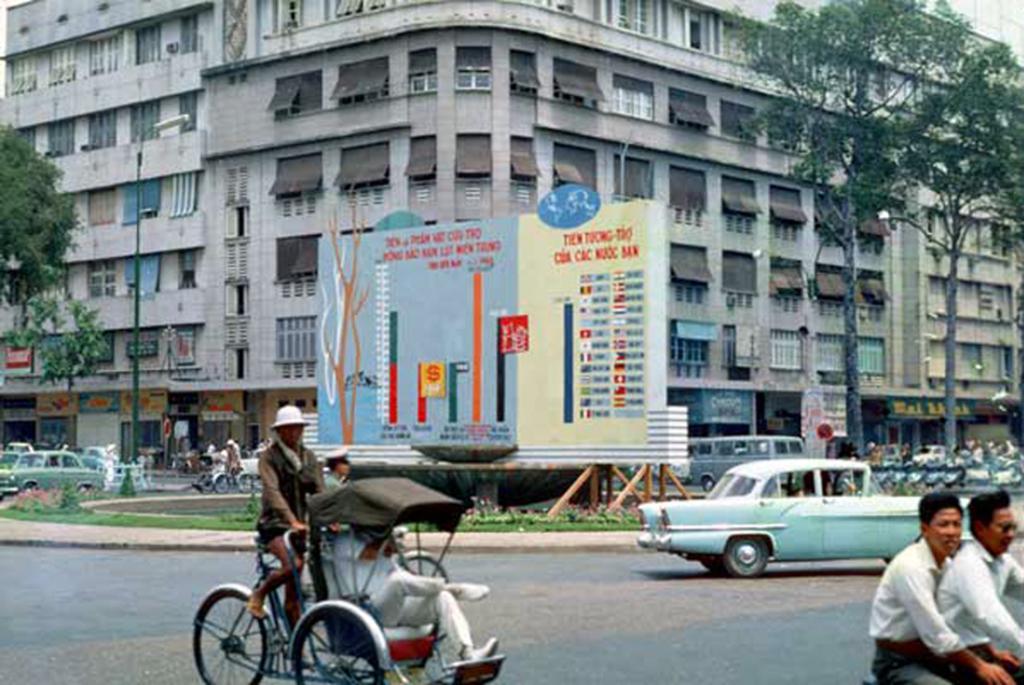Can you describe this image briefly? On the right side of the image, there are two persons sitting on the bike wearing two white color shirts. In the background, there is a car moving on the road, hoarding, trees, building, cars, grass and other items. On the left side of the image, a man is on the rickshaw is driving the rickshaw and other one is sitting in the rickshaw. 